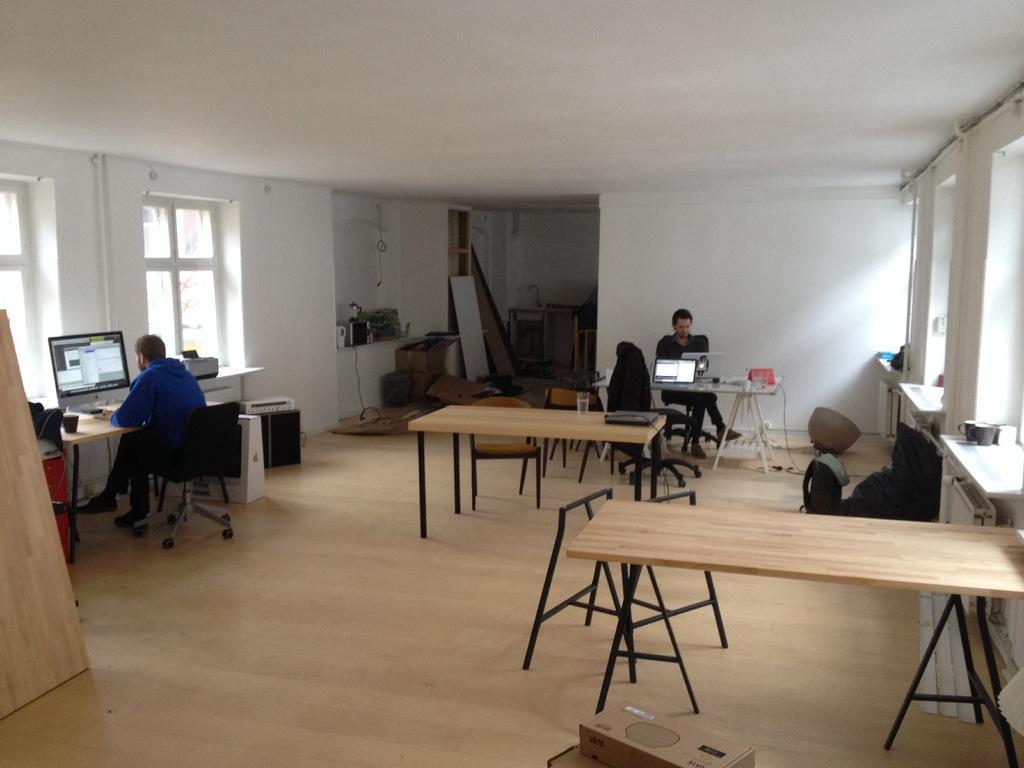Please provide a concise description of this image. This is the picture of a room where we have some tables around the room and chairs and there are two people sitting on the chairs in front of a desk which has systems and there are some left over things in the room. 